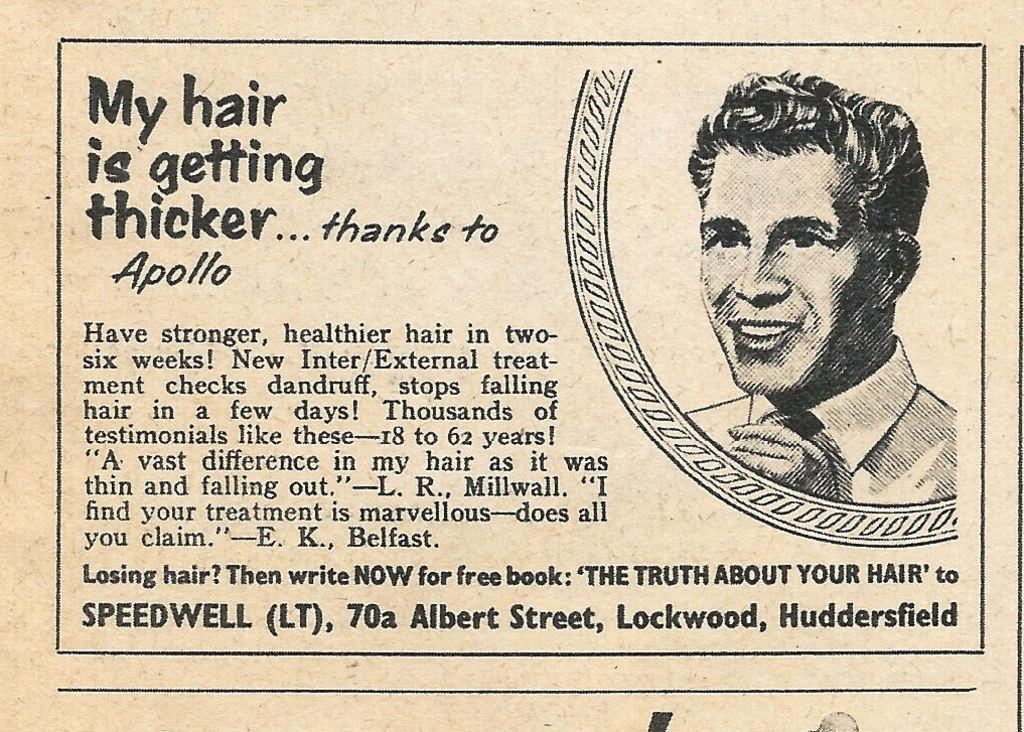What can be seen on the right side of the picture? There is an image of a person smiling on the right side of the picture. What is present on the left side of the picture? There are texts written on the left side of the picture. Can you see a stream flowing in the picture? There is no stream present in the picture; it features an image of a person smiling and texts on the left side. What type of spark is visible in the picture? There is no spark present in the picture. 